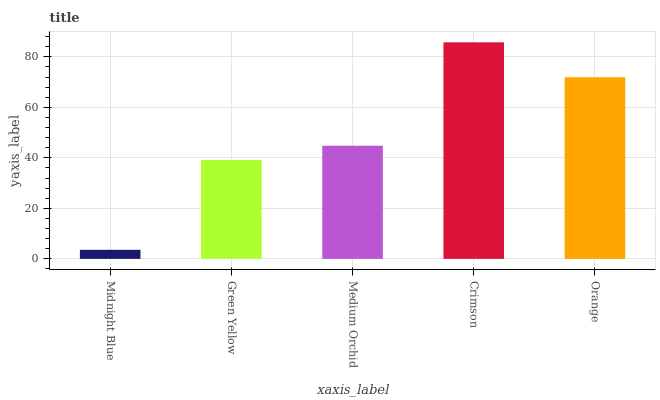Is Midnight Blue the minimum?
Answer yes or no. Yes. Is Crimson the maximum?
Answer yes or no. Yes. Is Green Yellow the minimum?
Answer yes or no. No. Is Green Yellow the maximum?
Answer yes or no. No. Is Green Yellow greater than Midnight Blue?
Answer yes or no. Yes. Is Midnight Blue less than Green Yellow?
Answer yes or no. Yes. Is Midnight Blue greater than Green Yellow?
Answer yes or no. No. Is Green Yellow less than Midnight Blue?
Answer yes or no. No. Is Medium Orchid the high median?
Answer yes or no. Yes. Is Medium Orchid the low median?
Answer yes or no. Yes. Is Orange the high median?
Answer yes or no. No. Is Midnight Blue the low median?
Answer yes or no. No. 